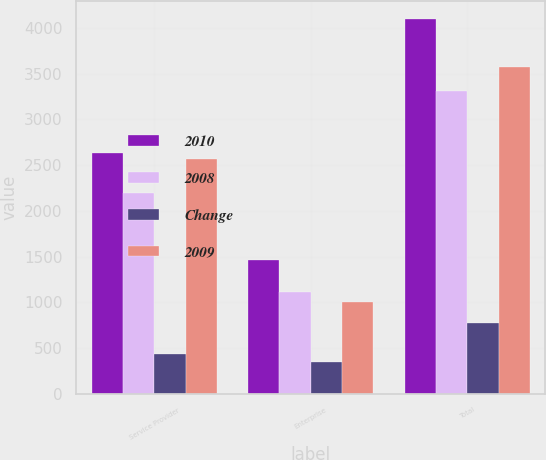Convert chart. <chart><loc_0><loc_0><loc_500><loc_500><stacked_bar_chart><ecel><fcel>Service Provider<fcel>Enterprise<fcel>Total<nl><fcel>2010<fcel>2631.5<fcel>1461.8<fcel>4093.3<nl><fcel>2008<fcel>2197.1<fcel>1118.8<fcel>3315.9<nl><fcel>Change<fcel>434.4<fcel>343<fcel>777.4<nl><fcel>2009<fcel>2568.2<fcel>1004.2<fcel>3572.4<nl></chart> 